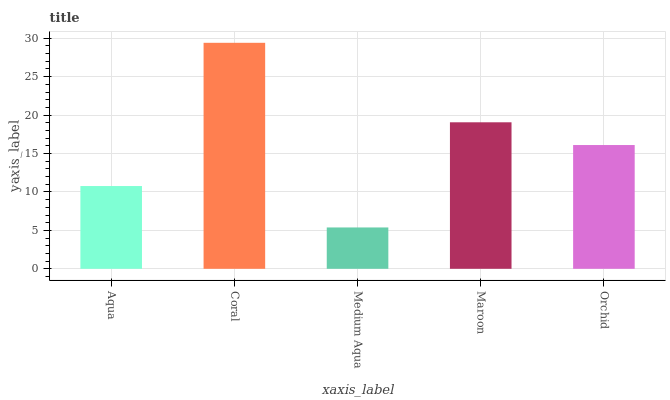Is Medium Aqua the minimum?
Answer yes or no. Yes. Is Coral the maximum?
Answer yes or no. Yes. Is Coral the minimum?
Answer yes or no. No. Is Medium Aqua the maximum?
Answer yes or no. No. Is Coral greater than Medium Aqua?
Answer yes or no. Yes. Is Medium Aqua less than Coral?
Answer yes or no. Yes. Is Medium Aqua greater than Coral?
Answer yes or no. No. Is Coral less than Medium Aqua?
Answer yes or no. No. Is Orchid the high median?
Answer yes or no. Yes. Is Orchid the low median?
Answer yes or no. Yes. Is Coral the high median?
Answer yes or no. No. Is Maroon the low median?
Answer yes or no. No. 